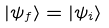<formula> <loc_0><loc_0><loc_500><loc_500>| \psi _ { f } \rangle = | \psi _ { i } \rangle</formula> 